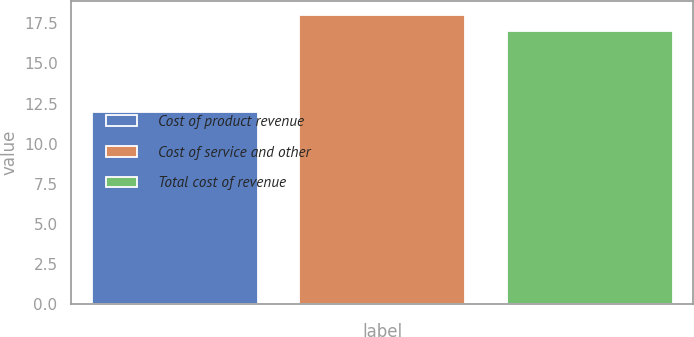<chart> <loc_0><loc_0><loc_500><loc_500><bar_chart><fcel>Cost of product revenue<fcel>Cost of service and other<fcel>Total cost of revenue<nl><fcel>12<fcel>18<fcel>17<nl></chart> 